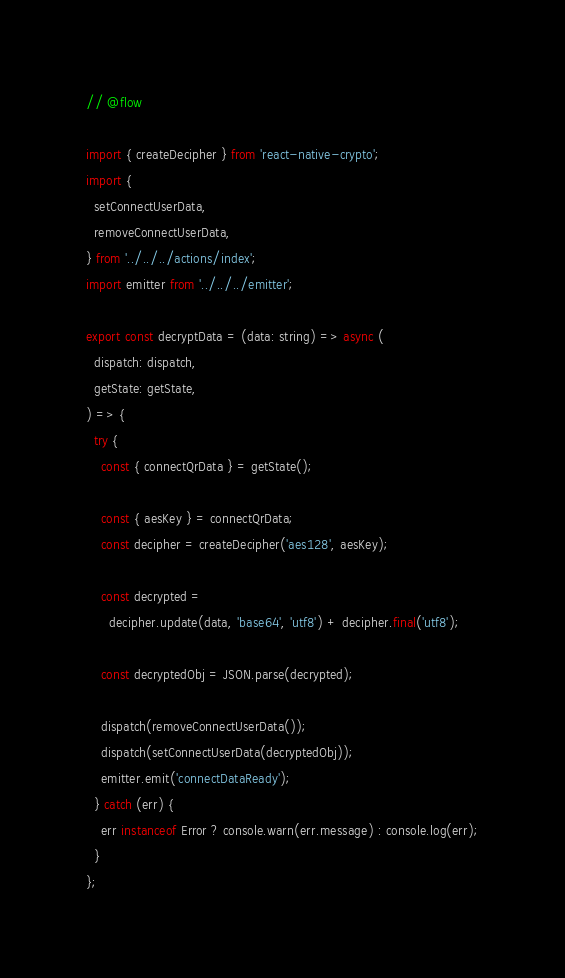Convert code to text. <code><loc_0><loc_0><loc_500><loc_500><_JavaScript_>// @flow

import { createDecipher } from 'react-native-crypto';
import {
  setConnectUserData,
  removeConnectUserData,
} from '../../../actions/index';
import emitter from '../../../emitter';

export const decryptData = (data: string) => async (
  dispatch: dispatch,
  getState: getState,
) => {
  try {
    const { connectQrData } = getState();

    const { aesKey } = connectQrData;
    const decipher = createDecipher('aes128', aesKey);

    const decrypted =
      decipher.update(data, 'base64', 'utf8') + decipher.final('utf8');

    const decryptedObj = JSON.parse(decrypted);

    dispatch(removeConnectUserData());
    dispatch(setConnectUserData(decryptedObj));
    emitter.emit('connectDataReady');
  } catch (err) {
    err instanceof Error ? console.warn(err.message) : console.log(err);
  }
};
</code> 